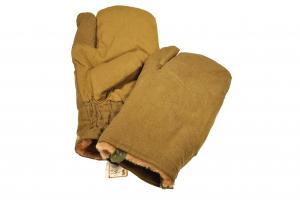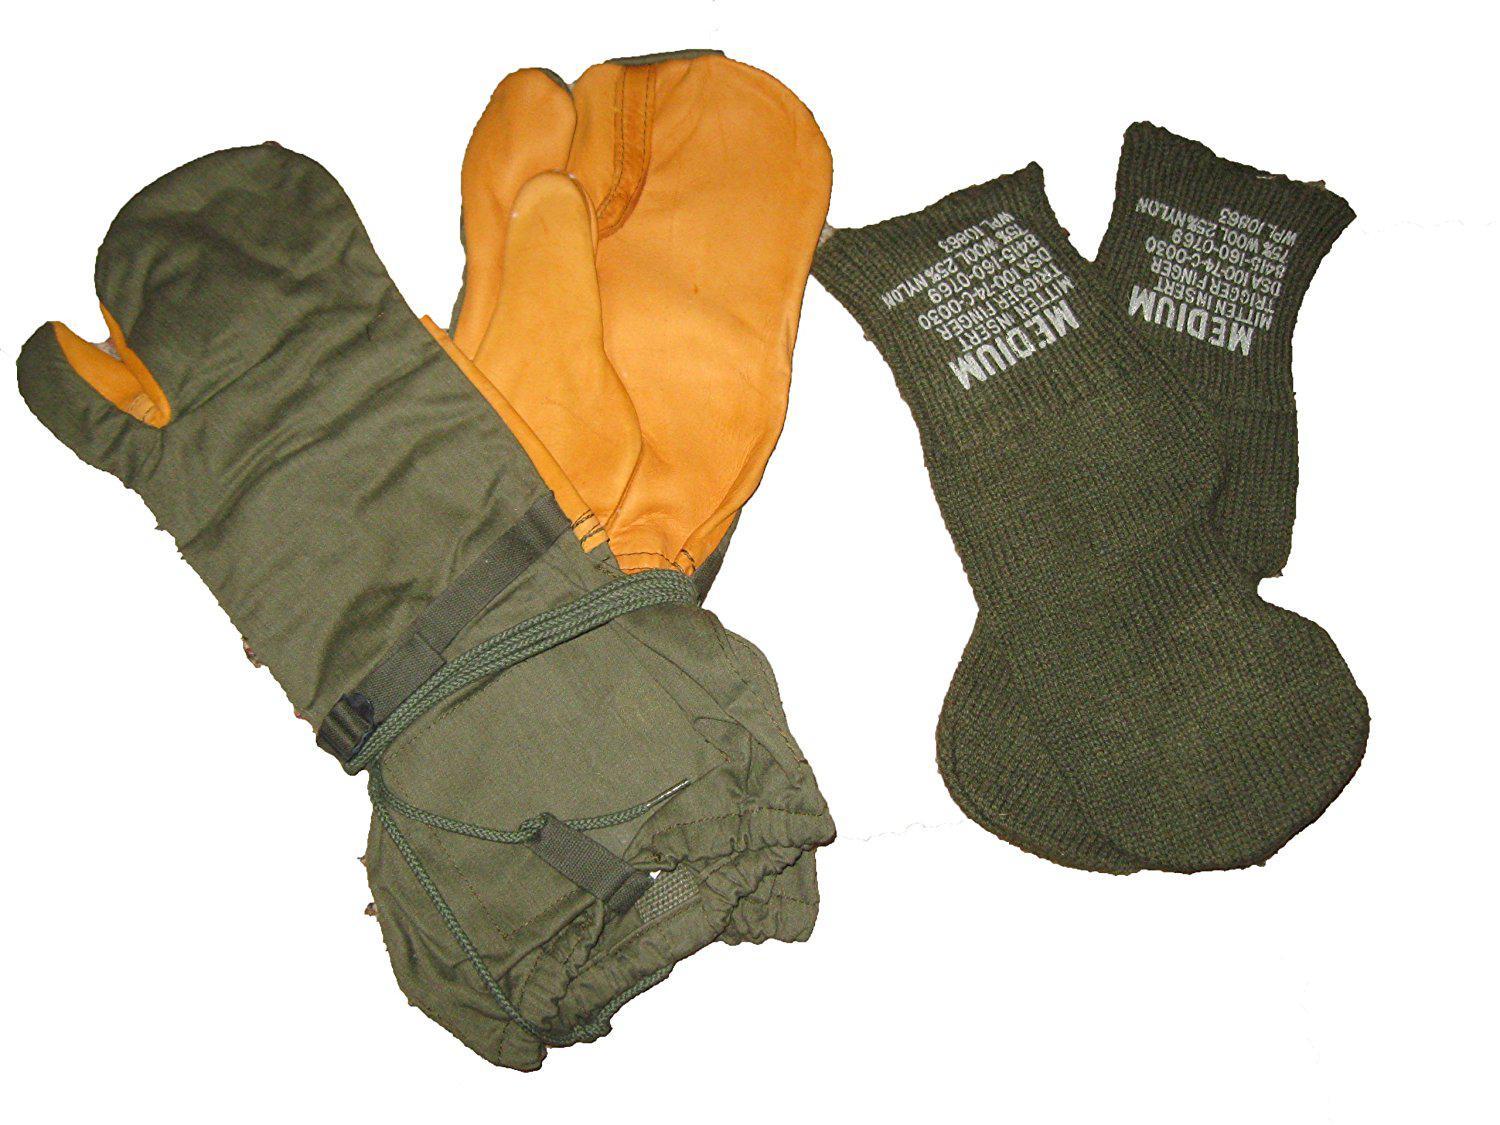The first image is the image on the left, the second image is the image on the right. Assess this claim about the two images: "Someone is wearing one of the gloves.". Correct or not? Answer yes or no. No. The first image is the image on the left, the second image is the image on the right. Given the left and right images, does the statement "In one image a pair of yellow-gold gloves are shown, the back view of one and the front view of the other, while the second image shows at least one similar glove with a human arm extended." hold true? Answer yes or no. No. 